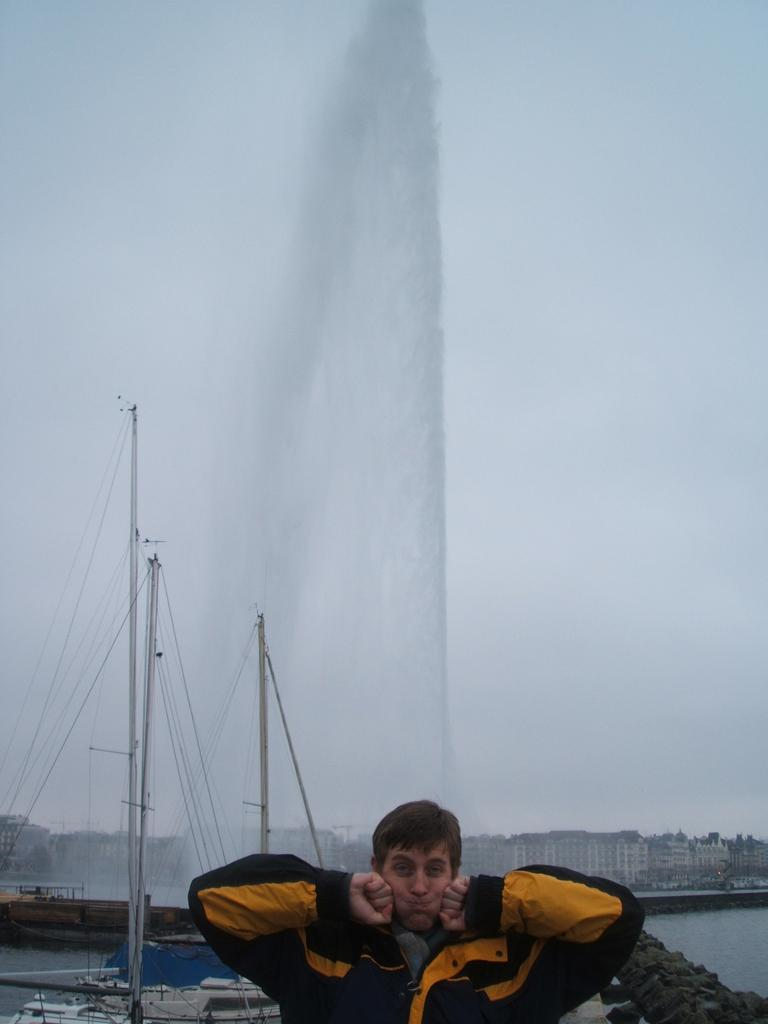What can be seen in the image? There is a person in the image. What is the person wearing? The person is wearing a black and yellow color jacket. What is the person doing with his hands? The person has both hands on his cheeks. What can be seen in the background of the image? There are boats, buildings, and water visible in the background of the image. What story is the person's uncle telling in the image? There is no mention of an uncle or a story in the image. 